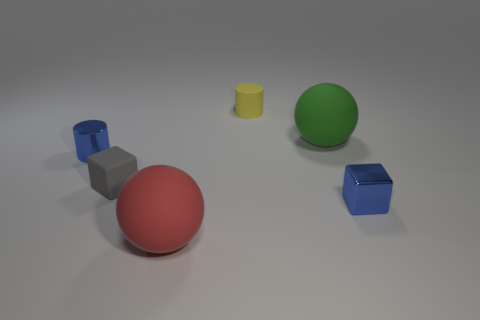Add 4 yellow matte things. How many objects exist? 10 Subtract all cylinders. How many objects are left? 4 Add 5 gray matte blocks. How many gray matte blocks are left? 6 Add 6 tiny yellow cylinders. How many tiny yellow cylinders exist? 7 Subtract 1 red spheres. How many objects are left? 5 Subtract all small metallic cubes. Subtract all large matte things. How many objects are left? 3 